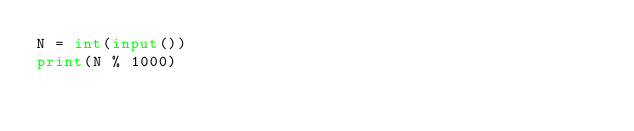<code> <loc_0><loc_0><loc_500><loc_500><_Python_>N = int(input())
print(N % 1000)</code> 